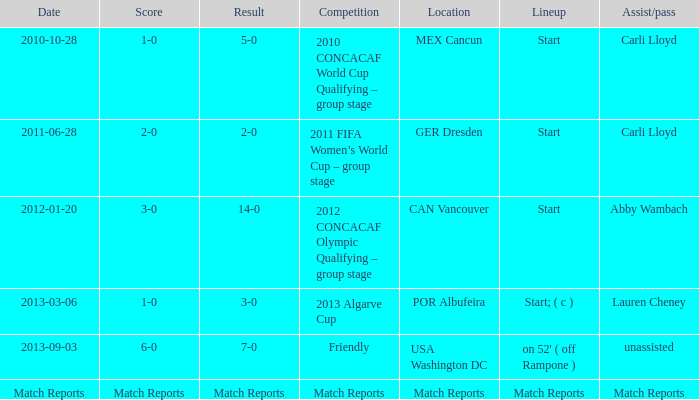Where has a score of match reports? Match Reports. 